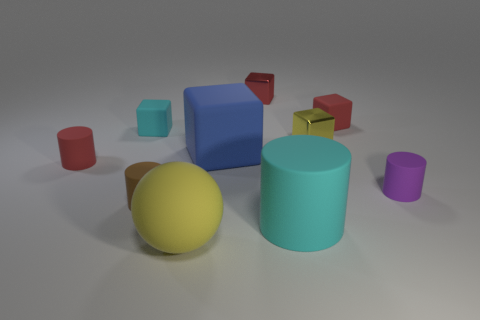Are there any patterns or repetitions visible in the image? In the image, there are repeated elements of geometric forms such as cylinders and blocks. These shapes vary in size and color but their fundamental forms are consistent throughout, creating a pattern of geometric regularity and repetition. What could be the purpose of arranging these objects in such a manner? The arrangement might serve a number of purposes. It could be a conceptual art piece emphasizing form and color, or it might be part of a visual study on composition and balance in 3D design. Another possibility is that it's a setting used to test visual algorithms, given the clear, defined shapes and varied colors against a neutral background. 